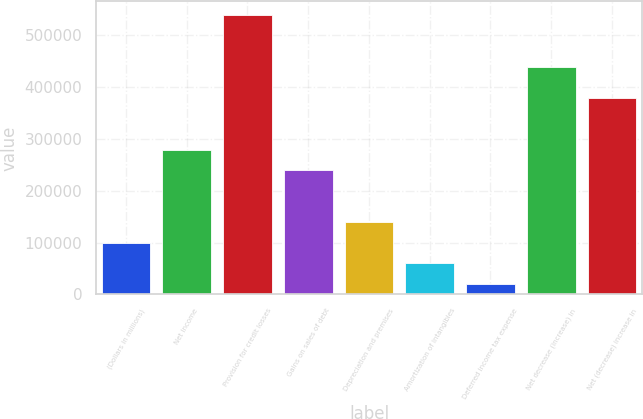Convert chart. <chart><loc_0><loc_0><loc_500><loc_500><bar_chart><fcel>(Dollars in millions)<fcel>Net income<fcel>Provision for credit losses<fcel>Gains on sales of debt<fcel>Depreciation and premises<fcel>Amortization of intangibles<fcel>Deferred income tax expense<fcel>Net decrease (increase) in<fcel>Net (decrease) increase in<nl><fcel>99805<fcel>279378<fcel>538762<fcel>239473<fcel>139710<fcel>59899.8<fcel>19994.6<fcel>438999<fcel>379141<nl></chart> 